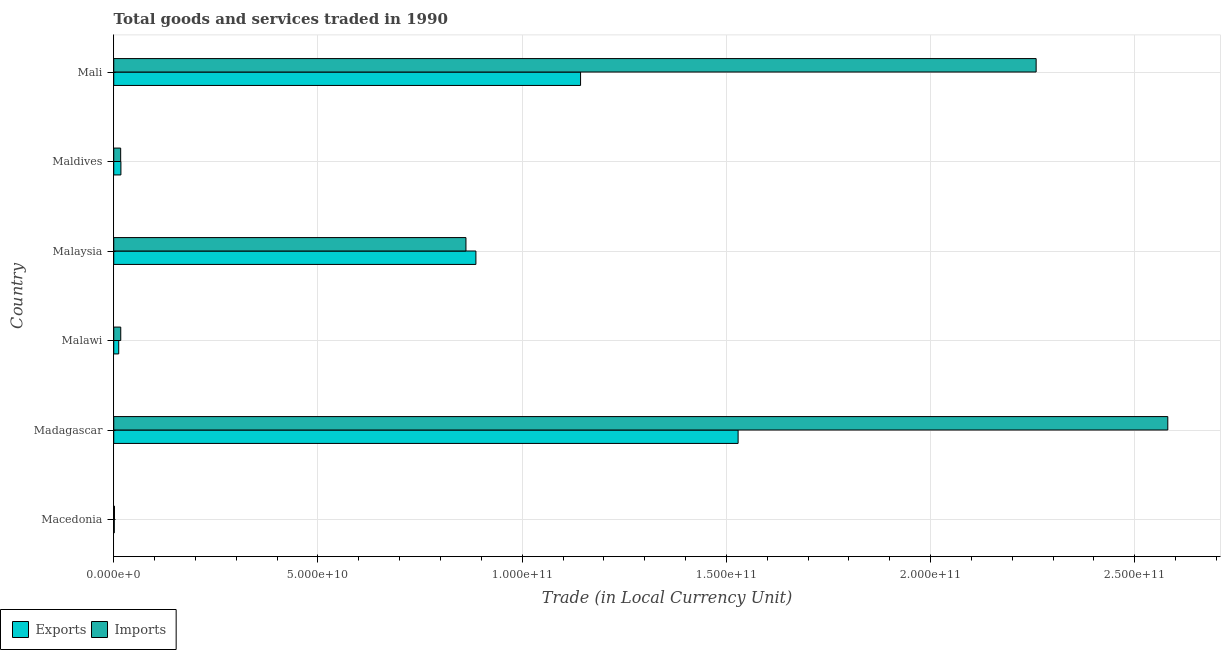How many different coloured bars are there?
Your answer should be compact. 2. How many groups of bars are there?
Your response must be concise. 6. Are the number of bars per tick equal to the number of legend labels?
Your response must be concise. Yes. What is the label of the 4th group of bars from the top?
Give a very brief answer. Malawi. What is the imports of goods and services in Malaysia?
Keep it short and to the point. 8.62e+1. Across all countries, what is the maximum imports of goods and services?
Your response must be concise. 2.58e+11. Across all countries, what is the minimum export of goods and services?
Your response must be concise. 1.31e+08. In which country was the export of goods and services maximum?
Make the answer very short. Madagascar. In which country was the imports of goods and services minimum?
Keep it short and to the point. Macedonia. What is the total imports of goods and services in the graph?
Offer a very short reply. 5.74e+11. What is the difference between the imports of goods and services in Madagascar and that in Malaysia?
Provide a succinct answer. 1.72e+11. What is the difference between the imports of goods and services in Macedonia and the export of goods and services in Malawi?
Your response must be concise. -1.04e+09. What is the average imports of goods and services per country?
Offer a terse response. 9.56e+1. What is the difference between the imports of goods and services and export of goods and services in Macedonia?
Your answer should be compact. 5.08e+07. What is the ratio of the imports of goods and services in Malaysia to that in Maldives?
Keep it short and to the point. 50.81. Is the difference between the export of goods and services in Malawi and Mali greater than the difference between the imports of goods and services in Malawi and Mali?
Make the answer very short. Yes. What is the difference between the highest and the second highest imports of goods and services?
Your answer should be compact. 3.22e+1. What is the difference between the highest and the lowest export of goods and services?
Keep it short and to the point. 1.53e+11. What does the 1st bar from the top in Maldives represents?
Offer a very short reply. Imports. What does the 1st bar from the bottom in Mali represents?
Make the answer very short. Exports. How many bars are there?
Provide a succinct answer. 12. Are all the bars in the graph horizontal?
Ensure brevity in your answer.  Yes. How many countries are there in the graph?
Give a very brief answer. 6. What is the difference between two consecutive major ticks on the X-axis?
Give a very brief answer. 5.00e+1. Are the values on the major ticks of X-axis written in scientific E-notation?
Keep it short and to the point. Yes. Does the graph contain any zero values?
Keep it short and to the point. No. How are the legend labels stacked?
Provide a short and direct response. Horizontal. What is the title of the graph?
Keep it short and to the point. Total goods and services traded in 1990. What is the label or title of the X-axis?
Your answer should be compact. Trade (in Local Currency Unit). What is the Trade (in Local Currency Unit) in Exports in Macedonia?
Offer a very short reply. 1.31e+08. What is the Trade (in Local Currency Unit) of Imports in Macedonia?
Make the answer very short. 1.82e+08. What is the Trade (in Local Currency Unit) in Exports in Madagascar?
Provide a short and direct response. 1.53e+11. What is the Trade (in Local Currency Unit) of Imports in Madagascar?
Offer a terse response. 2.58e+11. What is the Trade (in Local Currency Unit) of Exports in Malawi?
Provide a succinct answer. 1.22e+09. What is the Trade (in Local Currency Unit) of Imports in Malawi?
Your response must be concise. 1.72e+09. What is the Trade (in Local Currency Unit) in Exports in Malaysia?
Ensure brevity in your answer.  8.87e+1. What is the Trade (in Local Currency Unit) of Imports in Malaysia?
Keep it short and to the point. 8.62e+1. What is the Trade (in Local Currency Unit) of Exports in Maldives?
Ensure brevity in your answer.  1.76e+09. What is the Trade (in Local Currency Unit) of Imports in Maldives?
Your response must be concise. 1.70e+09. What is the Trade (in Local Currency Unit) in Exports in Mali?
Offer a terse response. 1.14e+11. What is the Trade (in Local Currency Unit) in Imports in Mali?
Provide a short and direct response. 2.26e+11. Across all countries, what is the maximum Trade (in Local Currency Unit) in Exports?
Your answer should be compact. 1.53e+11. Across all countries, what is the maximum Trade (in Local Currency Unit) of Imports?
Give a very brief answer. 2.58e+11. Across all countries, what is the minimum Trade (in Local Currency Unit) of Exports?
Ensure brevity in your answer.  1.31e+08. Across all countries, what is the minimum Trade (in Local Currency Unit) of Imports?
Offer a very short reply. 1.82e+08. What is the total Trade (in Local Currency Unit) of Exports in the graph?
Provide a succinct answer. 3.59e+11. What is the total Trade (in Local Currency Unit) in Imports in the graph?
Provide a short and direct response. 5.74e+11. What is the difference between the Trade (in Local Currency Unit) of Exports in Macedonia and that in Madagascar?
Your response must be concise. -1.53e+11. What is the difference between the Trade (in Local Currency Unit) of Imports in Macedonia and that in Madagascar?
Give a very brief answer. -2.58e+11. What is the difference between the Trade (in Local Currency Unit) in Exports in Macedonia and that in Malawi?
Ensure brevity in your answer.  -1.09e+09. What is the difference between the Trade (in Local Currency Unit) in Imports in Macedonia and that in Malawi?
Offer a terse response. -1.53e+09. What is the difference between the Trade (in Local Currency Unit) in Exports in Macedonia and that in Malaysia?
Your response must be concise. -8.85e+1. What is the difference between the Trade (in Local Currency Unit) of Imports in Macedonia and that in Malaysia?
Your response must be concise. -8.61e+1. What is the difference between the Trade (in Local Currency Unit) in Exports in Macedonia and that in Maldives?
Your response must be concise. -1.62e+09. What is the difference between the Trade (in Local Currency Unit) in Imports in Macedonia and that in Maldives?
Give a very brief answer. -1.52e+09. What is the difference between the Trade (in Local Currency Unit) in Exports in Macedonia and that in Mali?
Your answer should be compact. -1.14e+11. What is the difference between the Trade (in Local Currency Unit) in Imports in Macedonia and that in Mali?
Your answer should be very brief. -2.26e+11. What is the difference between the Trade (in Local Currency Unit) in Exports in Madagascar and that in Malawi?
Make the answer very short. 1.52e+11. What is the difference between the Trade (in Local Currency Unit) of Imports in Madagascar and that in Malawi?
Offer a very short reply. 2.56e+11. What is the difference between the Trade (in Local Currency Unit) of Exports in Madagascar and that in Malaysia?
Your answer should be compact. 6.42e+1. What is the difference between the Trade (in Local Currency Unit) in Imports in Madagascar and that in Malaysia?
Make the answer very short. 1.72e+11. What is the difference between the Trade (in Local Currency Unit) in Exports in Madagascar and that in Maldives?
Make the answer very short. 1.51e+11. What is the difference between the Trade (in Local Currency Unit) in Imports in Madagascar and that in Maldives?
Offer a terse response. 2.56e+11. What is the difference between the Trade (in Local Currency Unit) of Exports in Madagascar and that in Mali?
Your answer should be very brief. 3.86e+1. What is the difference between the Trade (in Local Currency Unit) in Imports in Madagascar and that in Mali?
Give a very brief answer. 3.22e+1. What is the difference between the Trade (in Local Currency Unit) in Exports in Malawi and that in Malaysia?
Ensure brevity in your answer.  -8.75e+1. What is the difference between the Trade (in Local Currency Unit) of Imports in Malawi and that in Malaysia?
Provide a succinct answer. -8.45e+1. What is the difference between the Trade (in Local Currency Unit) of Exports in Malawi and that in Maldives?
Make the answer very short. -5.35e+08. What is the difference between the Trade (in Local Currency Unit) of Imports in Malawi and that in Maldives?
Provide a succinct answer. 1.81e+07. What is the difference between the Trade (in Local Currency Unit) in Exports in Malawi and that in Mali?
Give a very brief answer. -1.13e+11. What is the difference between the Trade (in Local Currency Unit) in Imports in Malawi and that in Mali?
Give a very brief answer. -2.24e+11. What is the difference between the Trade (in Local Currency Unit) in Exports in Malaysia and that in Maldives?
Ensure brevity in your answer.  8.69e+1. What is the difference between the Trade (in Local Currency Unit) of Imports in Malaysia and that in Maldives?
Provide a succinct answer. 8.45e+1. What is the difference between the Trade (in Local Currency Unit) of Exports in Malaysia and that in Mali?
Make the answer very short. -2.56e+1. What is the difference between the Trade (in Local Currency Unit) in Imports in Malaysia and that in Mali?
Offer a very short reply. -1.40e+11. What is the difference between the Trade (in Local Currency Unit) in Exports in Maldives and that in Mali?
Ensure brevity in your answer.  -1.13e+11. What is the difference between the Trade (in Local Currency Unit) of Imports in Maldives and that in Mali?
Offer a very short reply. -2.24e+11. What is the difference between the Trade (in Local Currency Unit) in Exports in Macedonia and the Trade (in Local Currency Unit) in Imports in Madagascar?
Provide a succinct answer. -2.58e+11. What is the difference between the Trade (in Local Currency Unit) in Exports in Macedonia and the Trade (in Local Currency Unit) in Imports in Malawi?
Make the answer very short. -1.58e+09. What is the difference between the Trade (in Local Currency Unit) of Exports in Macedonia and the Trade (in Local Currency Unit) of Imports in Malaysia?
Keep it short and to the point. -8.61e+1. What is the difference between the Trade (in Local Currency Unit) of Exports in Macedonia and the Trade (in Local Currency Unit) of Imports in Maldives?
Make the answer very short. -1.57e+09. What is the difference between the Trade (in Local Currency Unit) in Exports in Macedonia and the Trade (in Local Currency Unit) in Imports in Mali?
Provide a short and direct response. -2.26e+11. What is the difference between the Trade (in Local Currency Unit) of Exports in Madagascar and the Trade (in Local Currency Unit) of Imports in Malawi?
Make the answer very short. 1.51e+11. What is the difference between the Trade (in Local Currency Unit) in Exports in Madagascar and the Trade (in Local Currency Unit) in Imports in Malaysia?
Make the answer very short. 6.66e+1. What is the difference between the Trade (in Local Currency Unit) of Exports in Madagascar and the Trade (in Local Currency Unit) of Imports in Maldives?
Provide a succinct answer. 1.51e+11. What is the difference between the Trade (in Local Currency Unit) of Exports in Madagascar and the Trade (in Local Currency Unit) of Imports in Mali?
Provide a succinct answer. -7.30e+1. What is the difference between the Trade (in Local Currency Unit) in Exports in Malawi and the Trade (in Local Currency Unit) in Imports in Malaysia?
Offer a very short reply. -8.50e+1. What is the difference between the Trade (in Local Currency Unit) of Exports in Malawi and the Trade (in Local Currency Unit) of Imports in Maldives?
Provide a short and direct response. -4.77e+08. What is the difference between the Trade (in Local Currency Unit) of Exports in Malawi and the Trade (in Local Currency Unit) of Imports in Mali?
Offer a very short reply. -2.25e+11. What is the difference between the Trade (in Local Currency Unit) in Exports in Malaysia and the Trade (in Local Currency Unit) in Imports in Maldives?
Make the answer very short. 8.70e+1. What is the difference between the Trade (in Local Currency Unit) of Exports in Malaysia and the Trade (in Local Currency Unit) of Imports in Mali?
Give a very brief answer. -1.37e+11. What is the difference between the Trade (in Local Currency Unit) of Exports in Maldives and the Trade (in Local Currency Unit) of Imports in Mali?
Offer a terse response. -2.24e+11. What is the average Trade (in Local Currency Unit) of Exports per country?
Keep it short and to the point. 5.98e+1. What is the average Trade (in Local Currency Unit) in Imports per country?
Provide a succinct answer. 9.56e+1. What is the difference between the Trade (in Local Currency Unit) of Exports and Trade (in Local Currency Unit) of Imports in Macedonia?
Offer a terse response. -5.08e+07. What is the difference between the Trade (in Local Currency Unit) of Exports and Trade (in Local Currency Unit) of Imports in Madagascar?
Your response must be concise. -1.05e+11. What is the difference between the Trade (in Local Currency Unit) of Exports and Trade (in Local Currency Unit) of Imports in Malawi?
Your response must be concise. -4.95e+08. What is the difference between the Trade (in Local Currency Unit) of Exports and Trade (in Local Currency Unit) of Imports in Malaysia?
Offer a very short reply. 2.43e+09. What is the difference between the Trade (in Local Currency Unit) in Exports and Trade (in Local Currency Unit) in Imports in Maldives?
Provide a short and direct response. 5.81e+07. What is the difference between the Trade (in Local Currency Unit) of Exports and Trade (in Local Currency Unit) of Imports in Mali?
Provide a short and direct response. -1.12e+11. What is the ratio of the Trade (in Local Currency Unit) in Exports in Macedonia to that in Madagascar?
Your answer should be very brief. 0. What is the ratio of the Trade (in Local Currency Unit) in Imports in Macedonia to that in Madagascar?
Make the answer very short. 0. What is the ratio of the Trade (in Local Currency Unit) of Exports in Macedonia to that in Malawi?
Make the answer very short. 0.11. What is the ratio of the Trade (in Local Currency Unit) of Imports in Macedonia to that in Malawi?
Give a very brief answer. 0.11. What is the ratio of the Trade (in Local Currency Unit) in Exports in Macedonia to that in Malaysia?
Give a very brief answer. 0. What is the ratio of the Trade (in Local Currency Unit) in Imports in Macedonia to that in Malaysia?
Give a very brief answer. 0. What is the ratio of the Trade (in Local Currency Unit) of Exports in Macedonia to that in Maldives?
Make the answer very short. 0.07. What is the ratio of the Trade (in Local Currency Unit) of Imports in Macedonia to that in Maldives?
Your answer should be compact. 0.11. What is the ratio of the Trade (in Local Currency Unit) in Exports in Macedonia to that in Mali?
Make the answer very short. 0. What is the ratio of the Trade (in Local Currency Unit) of Imports in Macedonia to that in Mali?
Keep it short and to the point. 0. What is the ratio of the Trade (in Local Currency Unit) of Exports in Madagascar to that in Malawi?
Your answer should be very brief. 125.25. What is the ratio of the Trade (in Local Currency Unit) in Imports in Madagascar to that in Malawi?
Provide a short and direct response. 150.46. What is the ratio of the Trade (in Local Currency Unit) in Exports in Madagascar to that in Malaysia?
Offer a terse response. 1.72. What is the ratio of the Trade (in Local Currency Unit) in Imports in Madagascar to that in Malaysia?
Offer a terse response. 2.99. What is the ratio of the Trade (in Local Currency Unit) of Exports in Madagascar to that in Maldives?
Give a very brief answer. 87.1. What is the ratio of the Trade (in Local Currency Unit) in Imports in Madagascar to that in Maldives?
Make the answer very short. 152.06. What is the ratio of the Trade (in Local Currency Unit) of Exports in Madagascar to that in Mali?
Ensure brevity in your answer.  1.34. What is the ratio of the Trade (in Local Currency Unit) in Imports in Madagascar to that in Mali?
Make the answer very short. 1.14. What is the ratio of the Trade (in Local Currency Unit) of Exports in Malawi to that in Malaysia?
Give a very brief answer. 0.01. What is the ratio of the Trade (in Local Currency Unit) in Imports in Malawi to that in Malaysia?
Ensure brevity in your answer.  0.02. What is the ratio of the Trade (in Local Currency Unit) in Exports in Malawi to that in Maldives?
Offer a terse response. 0.7. What is the ratio of the Trade (in Local Currency Unit) of Imports in Malawi to that in Maldives?
Offer a very short reply. 1.01. What is the ratio of the Trade (in Local Currency Unit) in Exports in Malawi to that in Mali?
Give a very brief answer. 0.01. What is the ratio of the Trade (in Local Currency Unit) in Imports in Malawi to that in Mali?
Make the answer very short. 0.01. What is the ratio of the Trade (in Local Currency Unit) of Exports in Malaysia to that in Maldives?
Provide a short and direct response. 50.52. What is the ratio of the Trade (in Local Currency Unit) in Imports in Malaysia to that in Maldives?
Keep it short and to the point. 50.81. What is the ratio of the Trade (in Local Currency Unit) in Exports in Malaysia to that in Mali?
Provide a short and direct response. 0.78. What is the ratio of the Trade (in Local Currency Unit) in Imports in Malaysia to that in Mali?
Provide a short and direct response. 0.38. What is the ratio of the Trade (in Local Currency Unit) of Exports in Maldives to that in Mali?
Your response must be concise. 0.02. What is the ratio of the Trade (in Local Currency Unit) of Imports in Maldives to that in Mali?
Ensure brevity in your answer.  0.01. What is the difference between the highest and the second highest Trade (in Local Currency Unit) in Exports?
Give a very brief answer. 3.86e+1. What is the difference between the highest and the second highest Trade (in Local Currency Unit) in Imports?
Your answer should be very brief. 3.22e+1. What is the difference between the highest and the lowest Trade (in Local Currency Unit) of Exports?
Your answer should be very brief. 1.53e+11. What is the difference between the highest and the lowest Trade (in Local Currency Unit) of Imports?
Provide a short and direct response. 2.58e+11. 